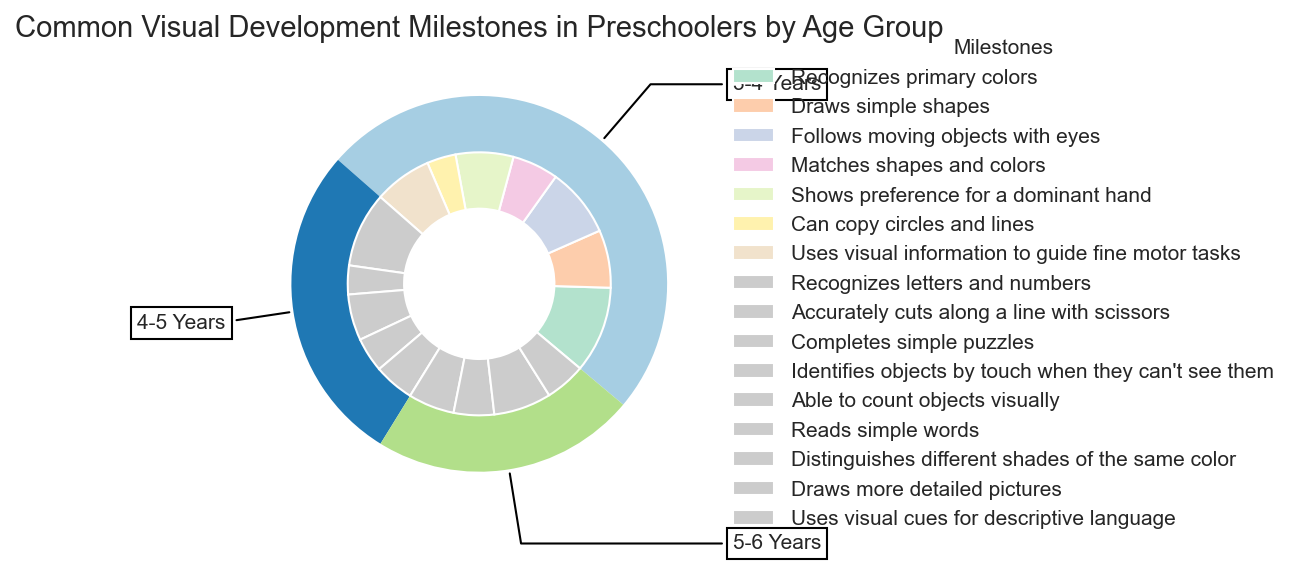Which age group has the highest percentage for milestones? The outer ring of the pie chart, representing the age groups, shows the size of each segment. The largest segment corresponds to the 3-4 Years group.
Answer: 3-4 Years What visual milestone is associated with the highest percentage for the 4-5 Years age group? In the inner ring of the pie chart, the segment with the largest size for the 4-5 Years age group is "Recognizes letters and numbers" at 13%.
Answer: Recognizes letters and numbers What is the combined percentage of "Draws simple shapes" and "Follows moving objects with eyes" for the 3-4 Years age group? For the 3-4 Years age group, sum the percentages for "Draws simple shapes" (10%) and "Follows moving objects with eyes" (12%). The combined percentage is 10% + 12% = 22%.
Answer: 22% Which age group has the smallest total percentage when combining all their milestones? Sum the percentages for each age group: 3-4 Years (70%), 4-5 Years (39%), 5-6 Years (32%). The smallest total percentage corresponds to the 5-6 Years age group.
Answer: 5-6 Years How does the percentage for "Uses visual information to guide fine motor tasks" (3-4 Years) compare to "Able to count objects visually" (4-5 Years)? "Uses visual information to guide fine motor tasks" for the 3-4 Years age group is 10%, while "Able to count objects visually" for the 4-5 Years age group is 7%. Thus, 10% is greater than 7%.
Answer: 10% > 7% Which milestone has the smallest percentage for the 5-6 Years age group? For the 5-6 Years age group, look at the smallest segment in the inner ring of the pie chart, which is "Distinguishes different shades of the same color" and "Uses visual cues for descriptive language," both at 7%.
Answer: Distinguishes different shades of the same color / Uses visual cues for descriptive language What is the difference in percentage points between "Recognizes primary colors" and "Draws simple shapes" for the 3-4 Years age group? For the 3-4 Years age group, "Recognizes primary colors" is 15% and "Draws simple shapes" is 10%. The difference is 15% - 10% = 5 percentage points.
Answer: 5 percentage points Which milestone is indicated by the lightest color in the inner ring for the 3-4 Years age group? Observing the shades in the inner ring, the lightest color segment for the 3-4 Years age group represents "Can copy circles and lines," which is 5%.
Answer: Can copy circles and lines How much more percentage does "Draws more detailed pictures" (5-6 Years) have compared to "Accurately cuts along a line with scissors" (4-5 Years)? "Draws more detailed pictures" for the 5-6 Years age group is 10%, and "Accurately cuts along a line with scissors" for the 4-5 Years age group is 5%. The difference is 10% - 5% = 5 percentage points.
Answer: 5 percentage points Which milestone appears to have a uniform color across all age groups? There is no milestone visually represented by the same color across all age groups, as each segment's color varies.
Answer: None 